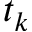<formula> <loc_0><loc_0><loc_500><loc_500>t _ { k }</formula> 